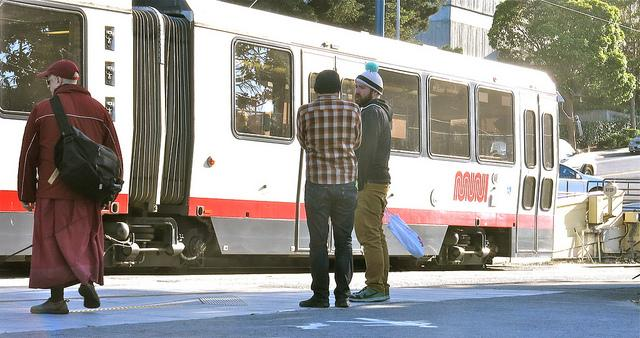What transmits electrical energy to the locomotive here? wires 